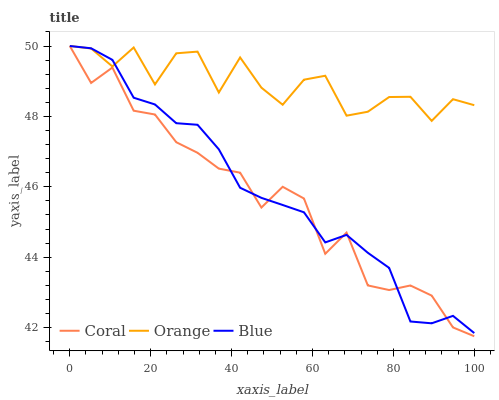Does Coral have the minimum area under the curve?
Answer yes or no. Yes. Does Orange have the maximum area under the curve?
Answer yes or no. Yes. Does Blue have the minimum area under the curve?
Answer yes or no. No. Does Blue have the maximum area under the curve?
Answer yes or no. No. Is Blue the smoothest?
Answer yes or no. Yes. Is Orange the roughest?
Answer yes or no. Yes. Is Coral the smoothest?
Answer yes or no. No. Is Coral the roughest?
Answer yes or no. No. Does Coral have the lowest value?
Answer yes or no. Yes. Does Blue have the lowest value?
Answer yes or no. No. Does Coral have the highest value?
Answer yes or no. Yes. Does Blue intersect Coral?
Answer yes or no. Yes. Is Blue less than Coral?
Answer yes or no. No. Is Blue greater than Coral?
Answer yes or no. No. 